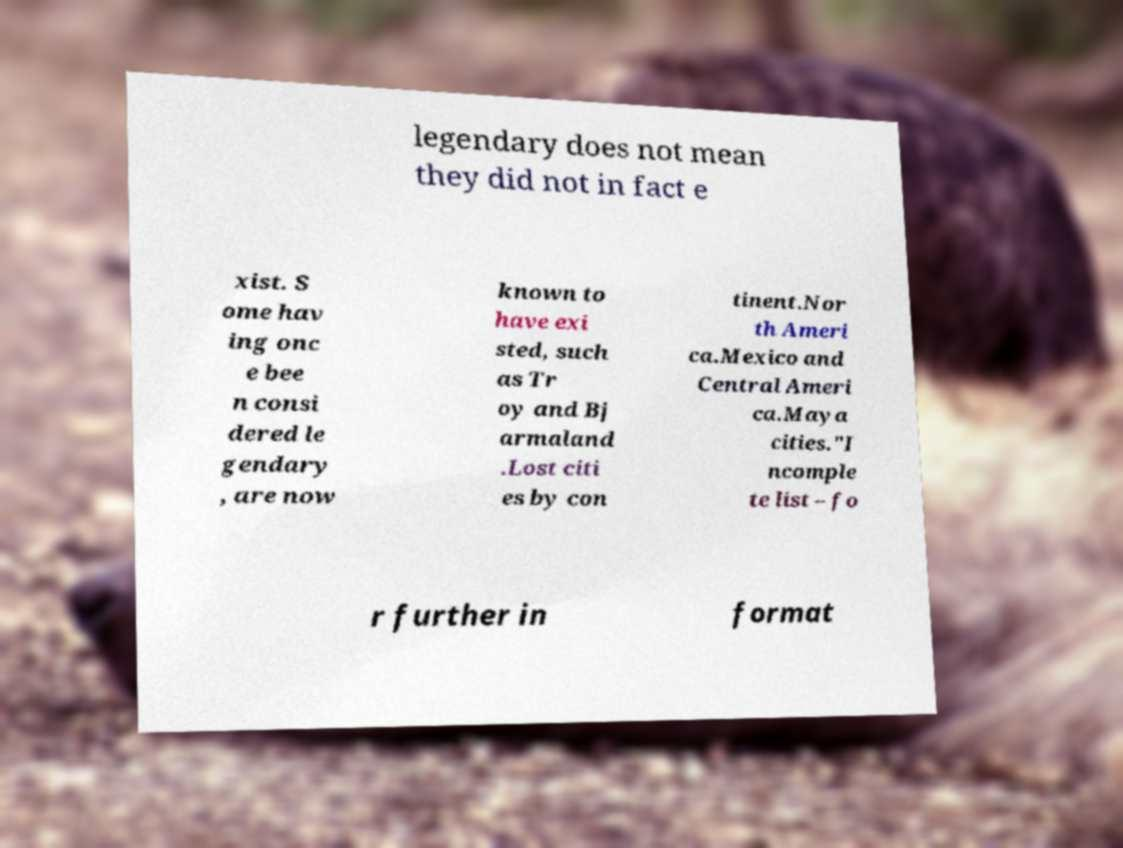Could you extract and type out the text from this image? legendary does not mean they did not in fact e xist. S ome hav ing onc e bee n consi dered le gendary , are now known to have exi sted, such as Tr oy and Bj armaland .Lost citi es by con tinent.Nor th Ameri ca.Mexico and Central Ameri ca.Maya cities."I ncomple te list – fo r further in format 